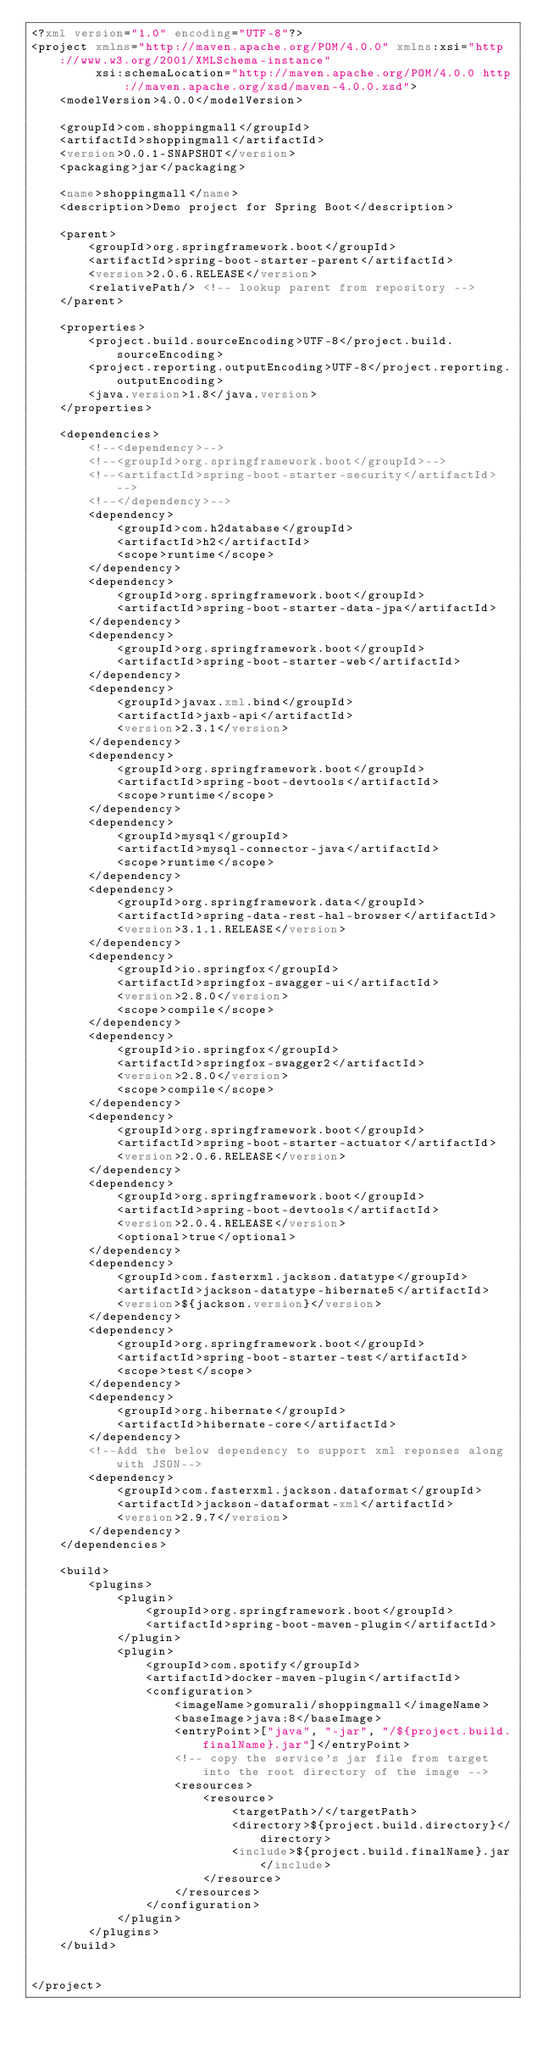Convert code to text. <code><loc_0><loc_0><loc_500><loc_500><_XML_><?xml version="1.0" encoding="UTF-8"?>
<project xmlns="http://maven.apache.org/POM/4.0.0" xmlns:xsi="http://www.w3.org/2001/XMLSchema-instance"
         xsi:schemaLocation="http://maven.apache.org/POM/4.0.0 http://maven.apache.org/xsd/maven-4.0.0.xsd">
    <modelVersion>4.0.0</modelVersion>

    <groupId>com.shoppingmall</groupId>
    <artifactId>shoppingmall</artifactId>
    <version>0.0.1-SNAPSHOT</version>
    <packaging>jar</packaging>

    <name>shoppingmall</name>
    <description>Demo project for Spring Boot</description>

    <parent>
        <groupId>org.springframework.boot</groupId>
        <artifactId>spring-boot-starter-parent</artifactId>
        <version>2.0.6.RELEASE</version>
        <relativePath/> <!-- lookup parent from repository -->
    </parent>

    <properties>
        <project.build.sourceEncoding>UTF-8</project.build.sourceEncoding>
        <project.reporting.outputEncoding>UTF-8</project.reporting.outputEncoding>
        <java.version>1.8</java.version>
    </properties>

    <dependencies>
        <!--<dependency>-->
        <!--<groupId>org.springframework.boot</groupId>-->
        <!--<artifactId>spring-boot-starter-security</artifactId>-->
        <!--</dependency>-->
        <dependency>
            <groupId>com.h2database</groupId>
            <artifactId>h2</artifactId>
            <scope>runtime</scope>
        </dependency>
        <dependency>
            <groupId>org.springframework.boot</groupId>
            <artifactId>spring-boot-starter-data-jpa</artifactId>
        </dependency>
        <dependency>
            <groupId>org.springframework.boot</groupId>
            <artifactId>spring-boot-starter-web</artifactId>
        </dependency>
        <dependency>
            <groupId>javax.xml.bind</groupId>
            <artifactId>jaxb-api</artifactId>
            <version>2.3.1</version>
        </dependency>
        <dependency>
            <groupId>org.springframework.boot</groupId>
            <artifactId>spring-boot-devtools</artifactId>
            <scope>runtime</scope>
        </dependency>
        <dependency>
            <groupId>mysql</groupId>
            <artifactId>mysql-connector-java</artifactId>
            <scope>runtime</scope>
        </dependency>
        <dependency>
            <groupId>org.springframework.data</groupId>
            <artifactId>spring-data-rest-hal-browser</artifactId>
            <version>3.1.1.RELEASE</version>
        </dependency>
        <dependency>
            <groupId>io.springfox</groupId>
            <artifactId>springfox-swagger-ui</artifactId>
            <version>2.8.0</version>
            <scope>compile</scope>
        </dependency>
        <dependency>
            <groupId>io.springfox</groupId>
            <artifactId>springfox-swagger2</artifactId>
            <version>2.8.0</version>
            <scope>compile</scope>
        </dependency>
        <dependency>
            <groupId>org.springframework.boot</groupId>
            <artifactId>spring-boot-starter-actuator</artifactId>
            <version>2.0.6.RELEASE</version>
        </dependency>
        <dependency>
            <groupId>org.springframework.boot</groupId>
            <artifactId>spring-boot-devtools</artifactId>
            <version>2.0.4.RELEASE</version>
            <optional>true</optional>
        </dependency>
        <dependency>
            <groupId>com.fasterxml.jackson.datatype</groupId>
            <artifactId>jackson-datatype-hibernate5</artifactId>
            <version>${jackson.version}</version>
        </dependency>
        <dependency>
            <groupId>org.springframework.boot</groupId>
            <artifactId>spring-boot-starter-test</artifactId>
            <scope>test</scope>
        </dependency>
        <dependency>
            <groupId>org.hibernate</groupId>
            <artifactId>hibernate-core</artifactId>
        </dependency>
        <!--Add the below dependency to support xml reponses along with JSON-->
        <dependency>
            <groupId>com.fasterxml.jackson.dataformat</groupId>
            <artifactId>jackson-dataformat-xml</artifactId>
            <version>2.9.7</version>
        </dependency>
    </dependencies>

    <build>
        <plugins>
            <plugin>
                <groupId>org.springframework.boot</groupId>
                <artifactId>spring-boot-maven-plugin</artifactId>
            </plugin>
            <plugin>
                <groupId>com.spotify</groupId>
                <artifactId>docker-maven-plugin</artifactId>
                <configuration>
                    <imageName>gomurali/shoppingmall</imageName>
                    <baseImage>java:8</baseImage>
                    <entryPoint>["java", "-jar", "/${project.build.finalName}.jar"]</entryPoint>
                    <!-- copy the service's jar file from target into the root directory of the image -->
                    <resources>
                        <resource>
                            <targetPath>/</targetPath>
                            <directory>${project.build.directory}</directory>
                            <include>${project.build.finalName}.jar</include>
                        </resource>
                    </resources>
                </configuration>
            </plugin>
        </plugins>
    </build>


</project>
</code> 